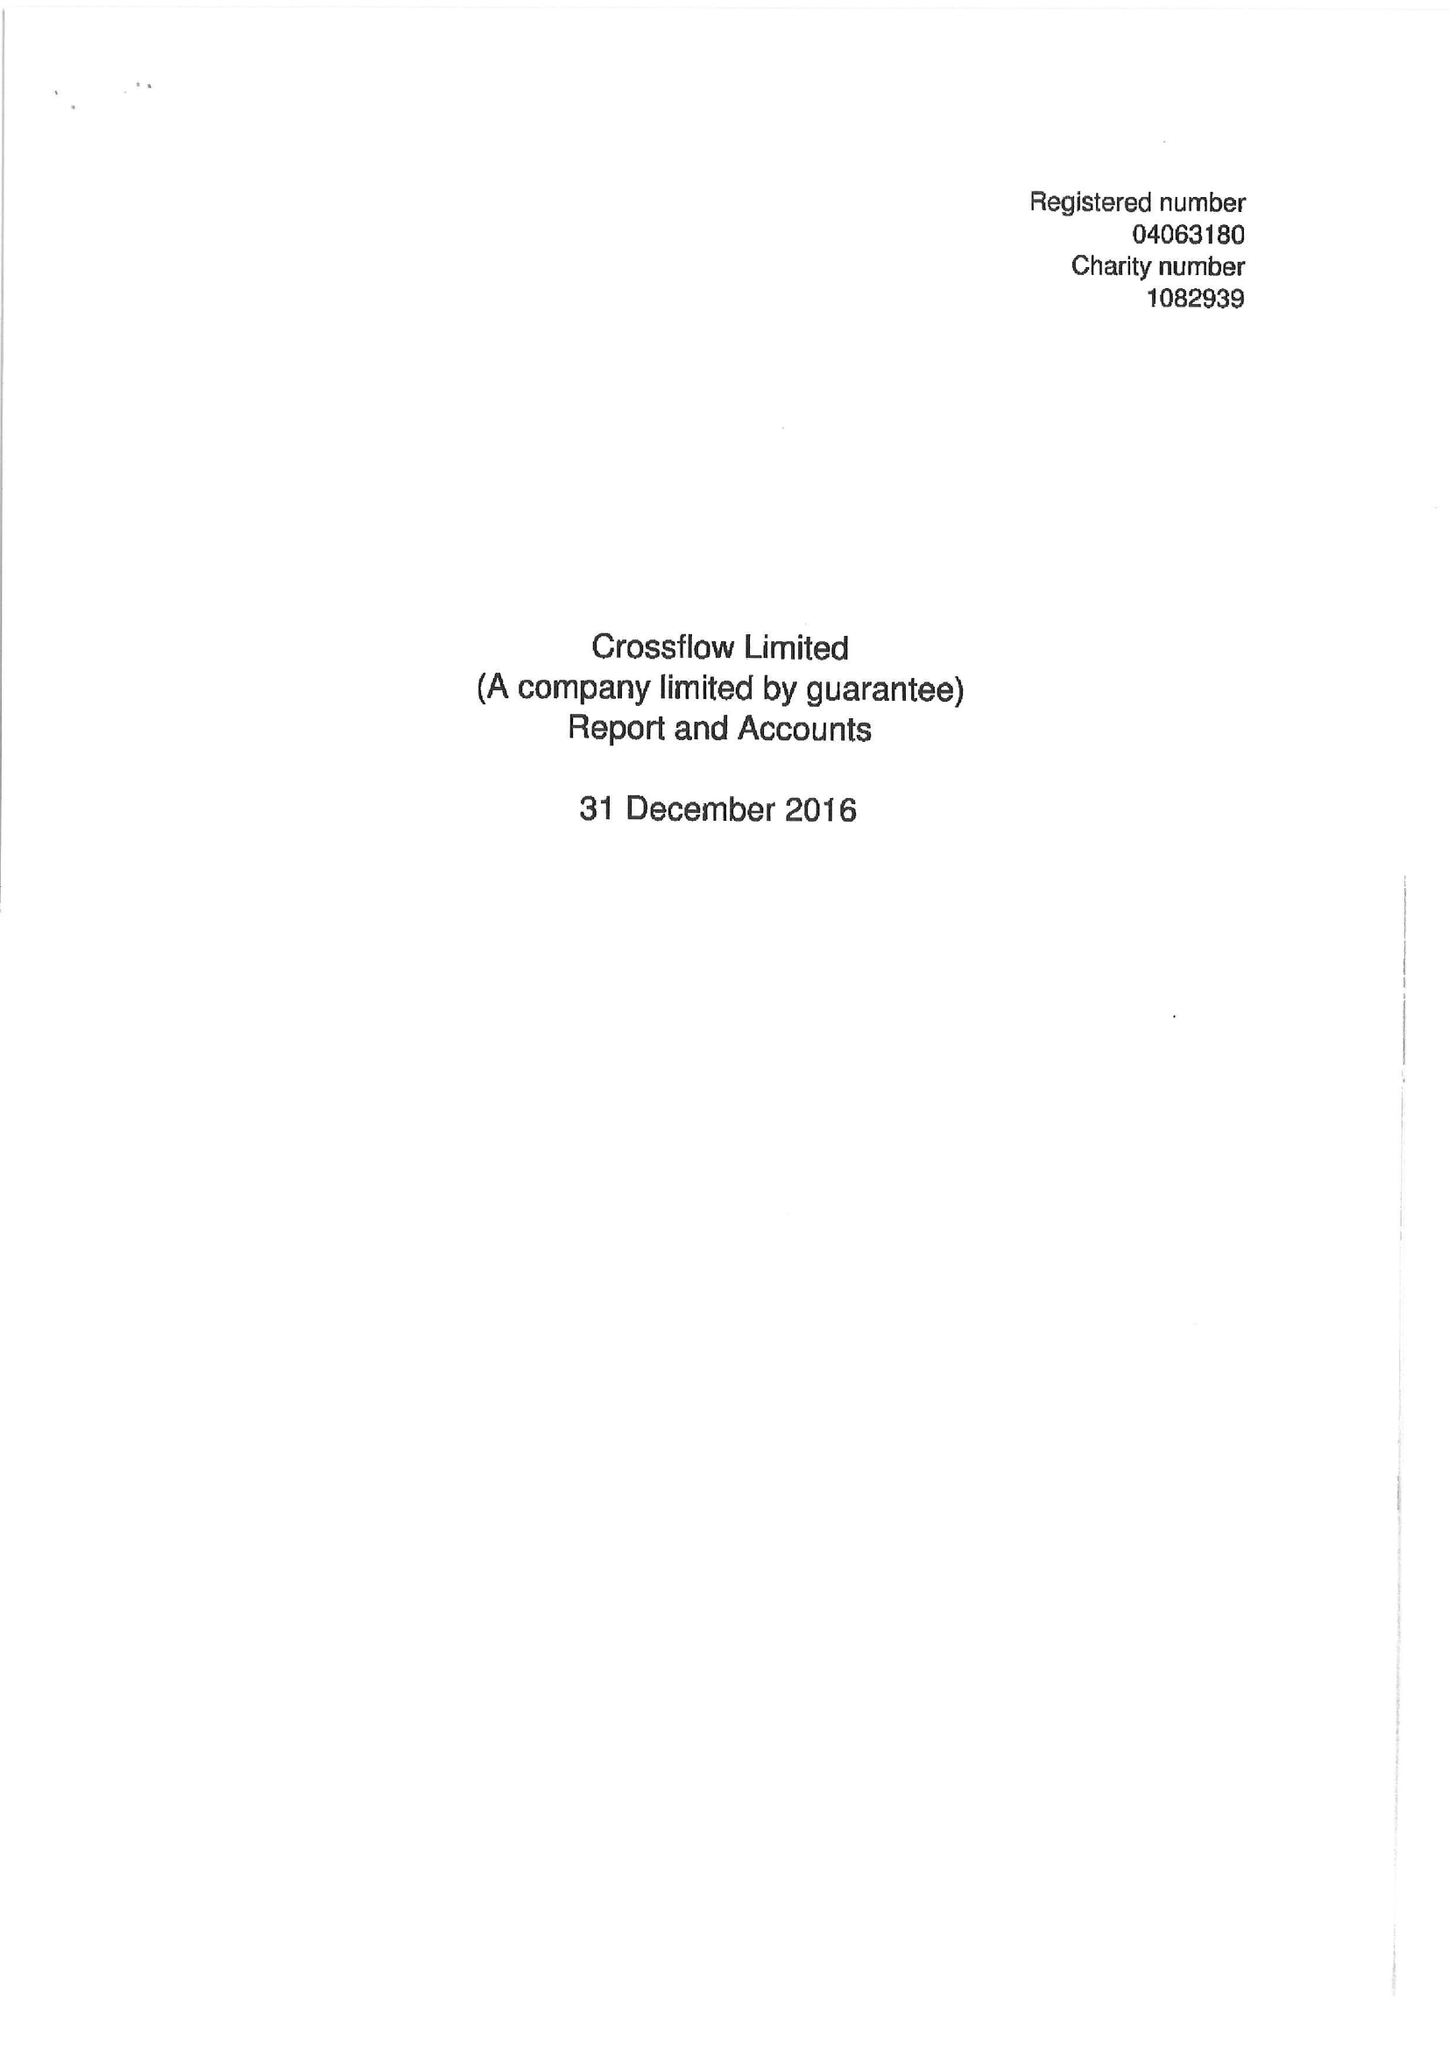What is the value for the spending_annually_in_british_pounds?
Answer the question using a single word or phrase. 146308.00 